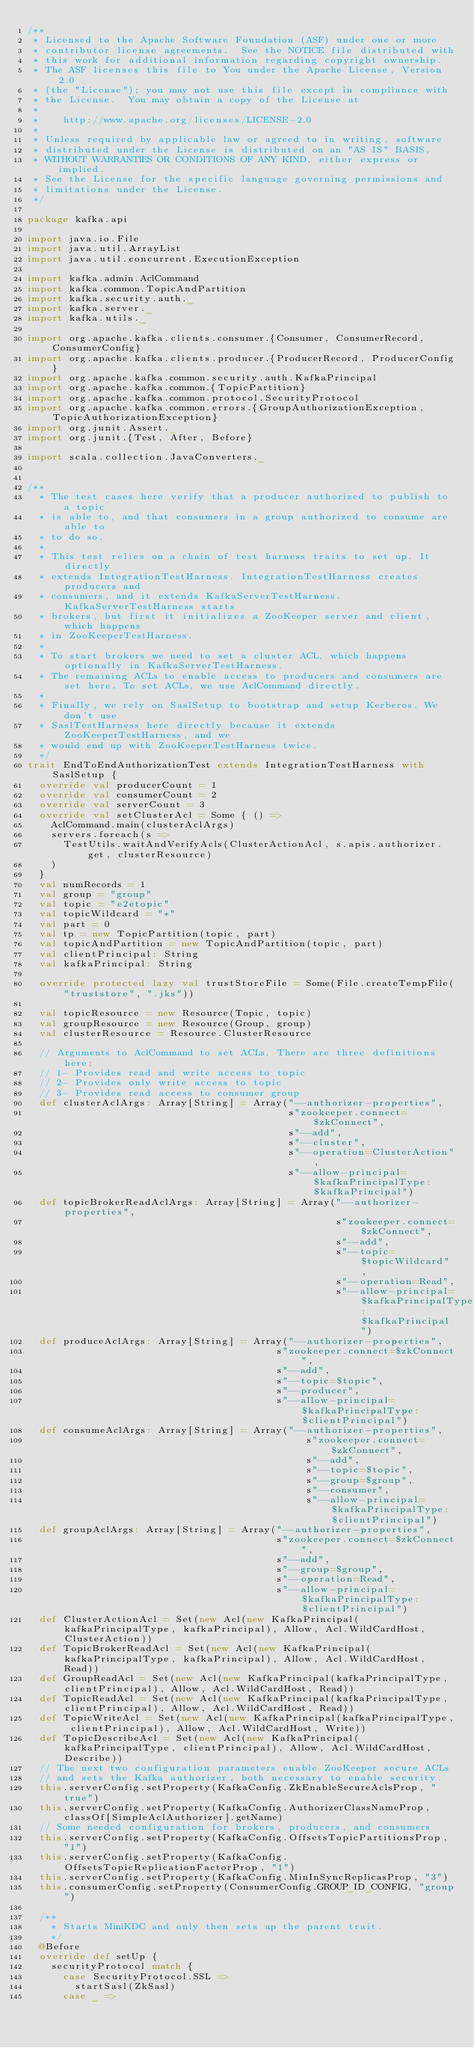Convert code to text. <code><loc_0><loc_0><loc_500><loc_500><_Scala_>/**
 * Licensed to the Apache Software Foundation (ASF) under one or more
 * contributor license agreements.  See the NOTICE file distributed with
 * this work for additional information regarding copyright ownership.
 * The ASF licenses this file to You under the Apache License, Version 2.0
 * (the "License"); you may not use this file except in compliance with
 * the License.  You may obtain a copy of the License at
 * 
 *    http://www.apache.org/licenses/LICENSE-2.0
 *
 * Unless required by applicable law or agreed to in writing, software
 * distributed under the License is distributed on an "AS IS" BASIS,
 * WITHOUT WARRANTIES OR CONDITIONS OF ANY KIND, either express or implied.
 * See the License for the specific language governing permissions and
 * limitations under the License.
 */

package kafka.api

import java.io.File
import java.util.ArrayList
import java.util.concurrent.ExecutionException

import kafka.admin.AclCommand
import kafka.common.TopicAndPartition
import kafka.security.auth._
import kafka.server._
import kafka.utils._

import org.apache.kafka.clients.consumer.{Consumer, ConsumerRecord, ConsumerConfig}
import org.apache.kafka.clients.producer.{ProducerRecord, ProducerConfig}
import org.apache.kafka.common.security.auth.KafkaPrincipal
import org.apache.kafka.common.{TopicPartition}
import org.apache.kafka.common.protocol.SecurityProtocol
import org.apache.kafka.common.errors.{GroupAuthorizationException,TopicAuthorizationException}
import org.junit.Assert._
import org.junit.{Test, After, Before}

import scala.collection.JavaConverters._


/**
  * The test cases here verify that a producer authorized to publish to a topic
  * is able to, and that consumers in a group authorized to consume are able to
  * to do so.
  *
  * This test relies on a chain of test harness traits to set up. It directly
  * extends IntegrationTestHarness. IntegrationTestHarness creates producers and
  * consumers, and it extends KafkaServerTestHarness. KafkaServerTestHarness starts
  * brokers, but first it initializes a ZooKeeper server and client, which happens
  * in ZooKeeperTestHarness.
  *
  * To start brokers we need to set a cluster ACL, which happens optionally in KafkaServerTestHarness.
  * The remaining ACLs to enable access to producers and consumers are set here. To set ACLs, we use AclCommand directly.
  *
  * Finally, we rely on SaslSetup to bootstrap and setup Kerberos. We don't use
  * SaslTestHarness here directly because it extends ZooKeeperTestHarness, and we
  * would end up with ZooKeeperTestHarness twice.
  */
trait EndToEndAuthorizationTest extends IntegrationTestHarness with SaslSetup {
  override val producerCount = 1
  override val consumerCount = 2
  override val serverCount = 3
  override val setClusterAcl = Some { () =>
    AclCommand.main(clusterAclArgs)
    servers.foreach(s =>
      TestUtils.waitAndVerifyAcls(ClusterActionAcl, s.apis.authorizer.get, clusterResource)
    )
  }
  val numRecords = 1
  val group = "group"
  val topic = "e2etopic"
  val topicWildcard = "*"
  val part = 0
  val tp = new TopicPartition(topic, part)
  val topicAndPartition = new TopicAndPartition(topic, part)
  val clientPrincipal: String
  val kafkaPrincipal: String

  override protected lazy val trustStoreFile = Some(File.createTempFile("truststore", ".jks"))

  val topicResource = new Resource(Topic, topic)
  val groupResource = new Resource(Group, group)
  val clusterResource = Resource.ClusterResource

  // Arguments to AclCommand to set ACLs. There are three definitions here:
  // 1- Provides read and write access to topic
  // 2- Provides only write access to topic
  // 3- Provides read access to consumer group
  def clusterAclArgs: Array[String] = Array("--authorizer-properties",
                                            s"zookeeper.connect=$zkConnect",
                                            s"--add",
                                            s"--cluster",
                                            s"--operation=ClusterAction",
                                            s"--allow-principal=$kafkaPrincipalType:$kafkaPrincipal")
  def topicBrokerReadAclArgs: Array[String] = Array("--authorizer-properties",
                                                    s"zookeeper.connect=$zkConnect",
                                                    s"--add",
                                                    s"--topic=$topicWildcard",
                                                    s"--operation=Read",
                                                    s"--allow-principal=$kafkaPrincipalType:$kafkaPrincipal")
  def produceAclArgs: Array[String] = Array("--authorizer-properties",
                                          s"zookeeper.connect=$zkConnect",
                                          s"--add",
                                          s"--topic=$topic",
                                          s"--producer",
                                          s"--allow-principal=$kafkaPrincipalType:$clientPrincipal")
  def consumeAclArgs: Array[String] = Array("--authorizer-properties",
                                               s"zookeeper.connect=$zkConnect",
                                               s"--add",
                                               s"--topic=$topic",
                                               s"--group=$group",
                                               s"--consumer",
                                               s"--allow-principal=$kafkaPrincipalType:$clientPrincipal")
  def groupAclArgs: Array[String] = Array("--authorizer-properties",
                                          s"zookeeper.connect=$zkConnect",
                                          s"--add",
                                          s"--group=$group",
                                          s"--operation=Read",
                                          s"--allow-principal=$kafkaPrincipalType:$clientPrincipal")
  def ClusterActionAcl = Set(new Acl(new KafkaPrincipal(kafkaPrincipalType, kafkaPrincipal), Allow, Acl.WildCardHost, ClusterAction))
  def TopicBrokerReadAcl = Set(new Acl(new KafkaPrincipal(kafkaPrincipalType, kafkaPrincipal), Allow, Acl.WildCardHost, Read))
  def GroupReadAcl = Set(new Acl(new KafkaPrincipal(kafkaPrincipalType, clientPrincipal), Allow, Acl.WildCardHost, Read))
  def TopicReadAcl = Set(new Acl(new KafkaPrincipal(kafkaPrincipalType, clientPrincipal), Allow, Acl.WildCardHost, Read))
  def TopicWriteAcl = Set(new Acl(new KafkaPrincipal(kafkaPrincipalType, clientPrincipal), Allow, Acl.WildCardHost, Write))
  def TopicDescribeAcl = Set(new Acl(new KafkaPrincipal(kafkaPrincipalType, clientPrincipal), Allow, Acl.WildCardHost, Describe))
  // The next two configuration parameters enable ZooKeeper secure ACLs
  // and sets the Kafka authorizer, both necessary to enable security.
  this.serverConfig.setProperty(KafkaConfig.ZkEnableSecureAclsProp, "true")
  this.serverConfig.setProperty(KafkaConfig.AuthorizerClassNameProp, classOf[SimpleAclAuthorizer].getName)
  // Some needed configuration for brokers, producers, and consumers
  this.serverConfig.setProperty(KafkaConfig.OffsetsTopicPartitionsProp, "1")
  this.serverConfig.setProperty(KafkaConfig.OffsetsTopicReplicationFactorProp, "1")
  this.serverConfig.setProperty(KafkaConfig.MinInSyncReplicasProp, "3")
  this.consumerConfig.setProperty(ConsumerConfig.GROUP_ID_CONFIG, "group")

  /**
    * Starts MiniKDC and only then sets up the parent trait.
    */
  @Before
  override def setUp {
    securityProtocol match {
      case SecurityProtocol.SSL =>
        startSasl(ZkSasl)
      case _ =></code> 